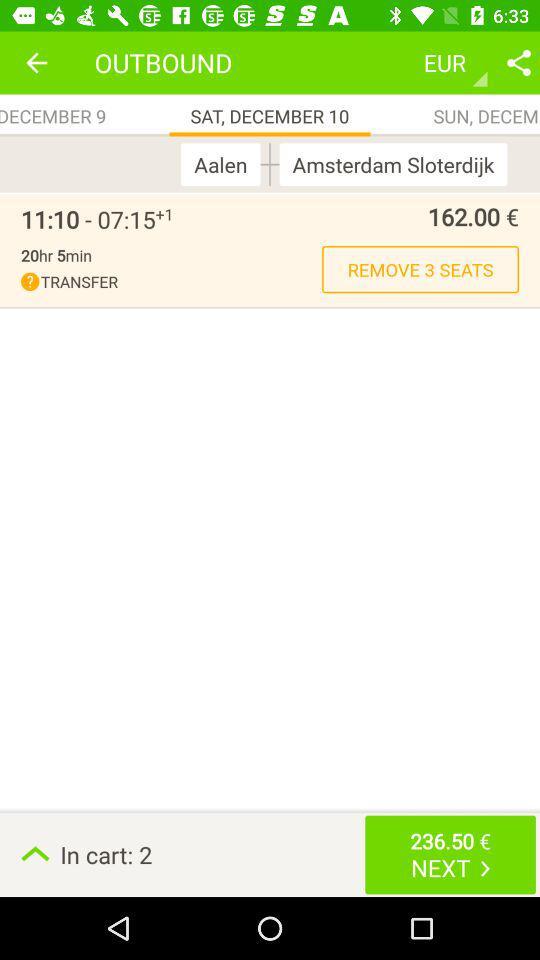How many days are there between the two departure dates?
Answer the question using a single word or phrase. 1 